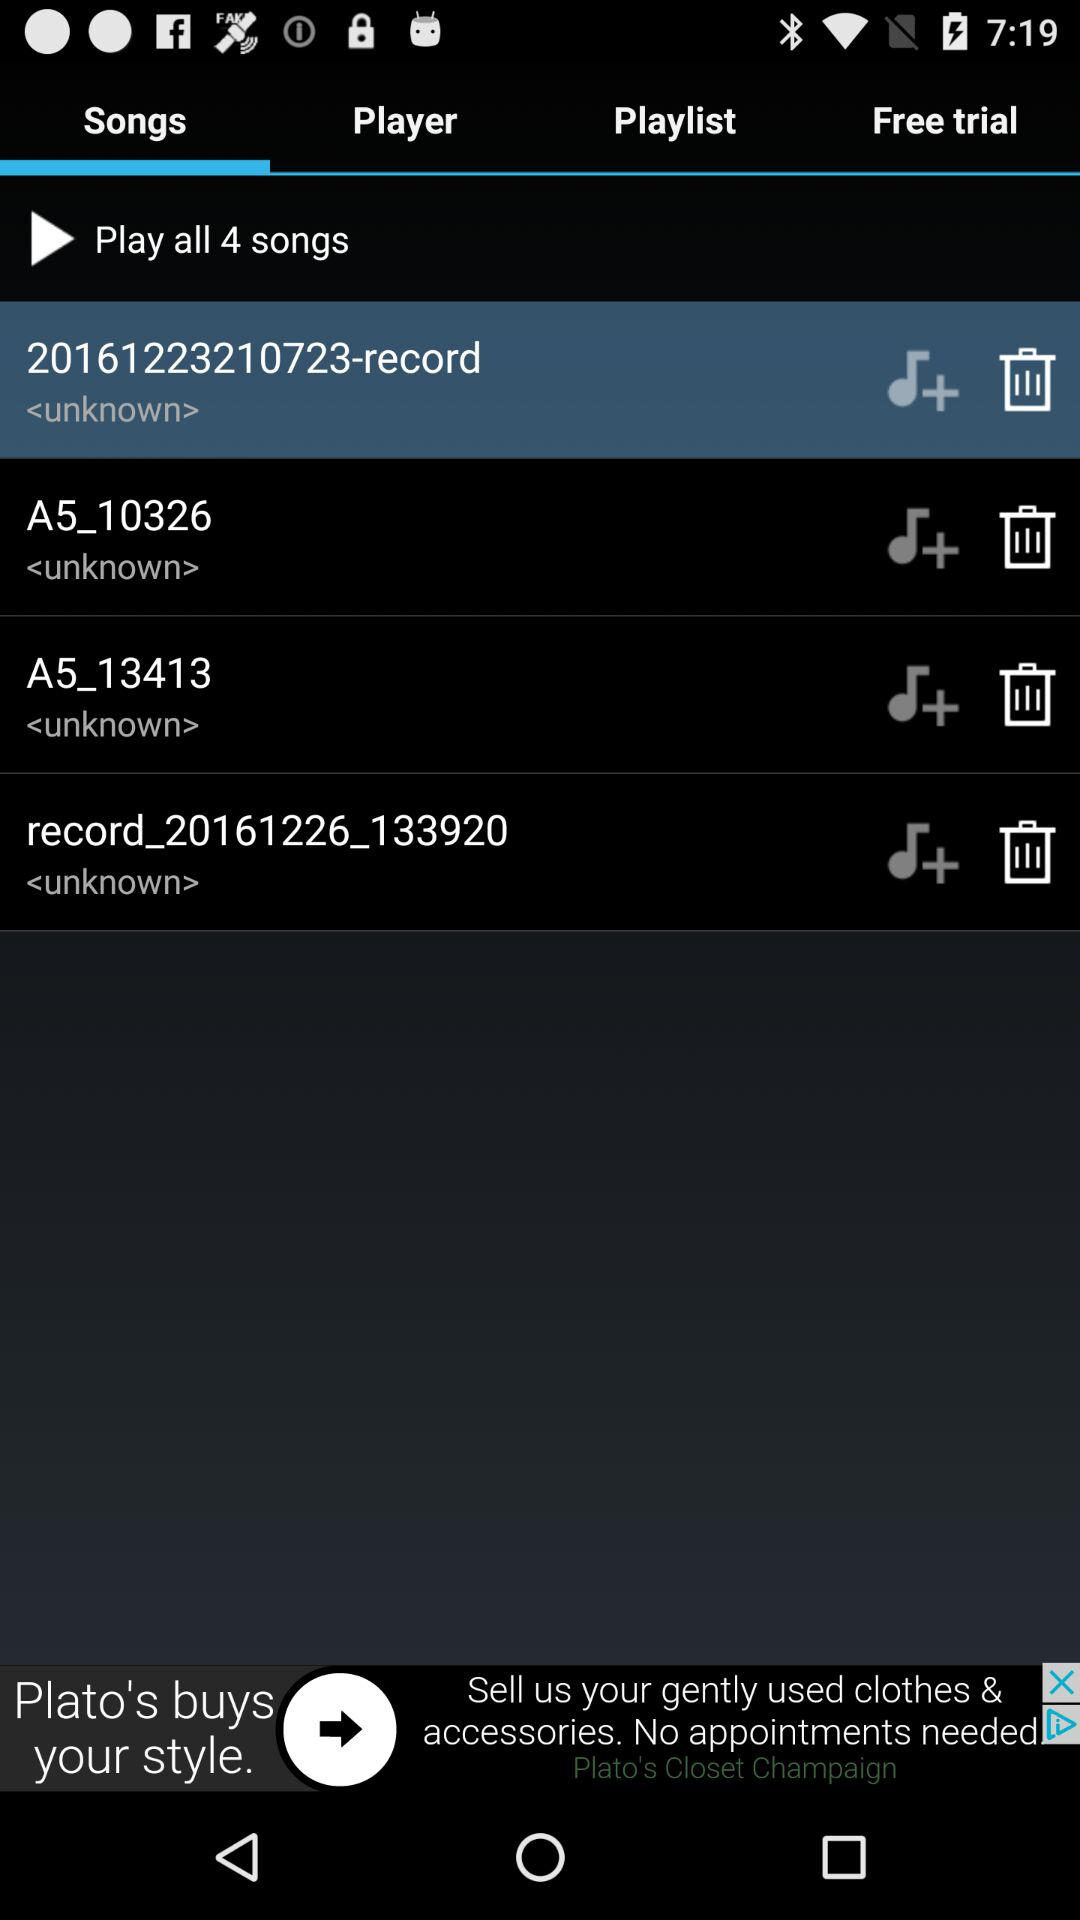What is the total number of songs? The total number of songs is 4. 